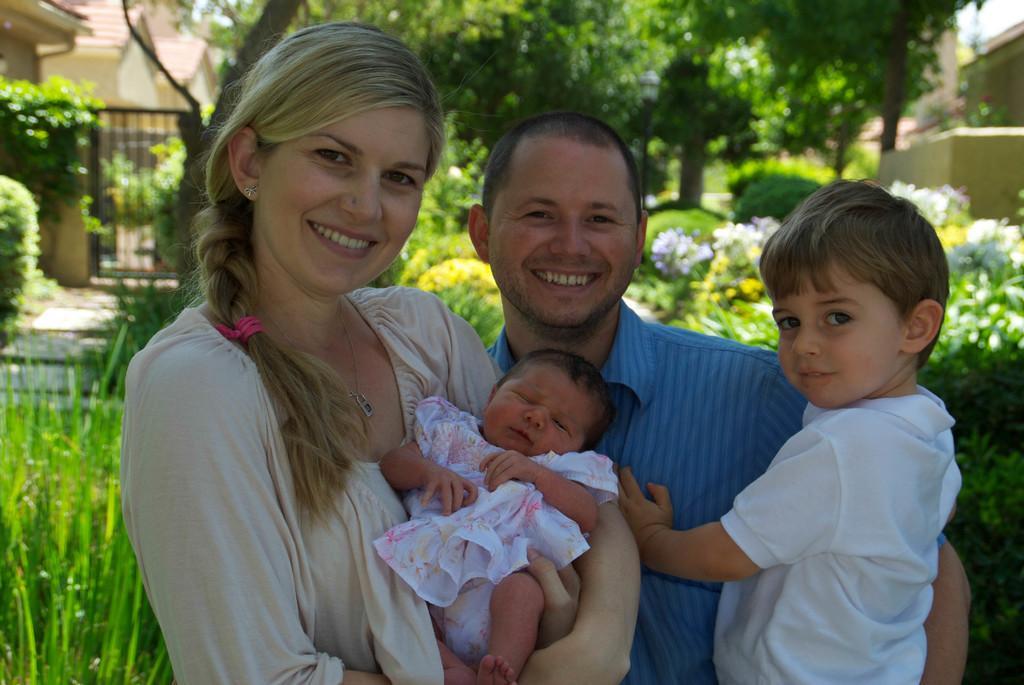Please provide a concise description of this image. As we can see in the image there are few people standing in the front, grass, plants, flowers, trees, gate and buildings. 